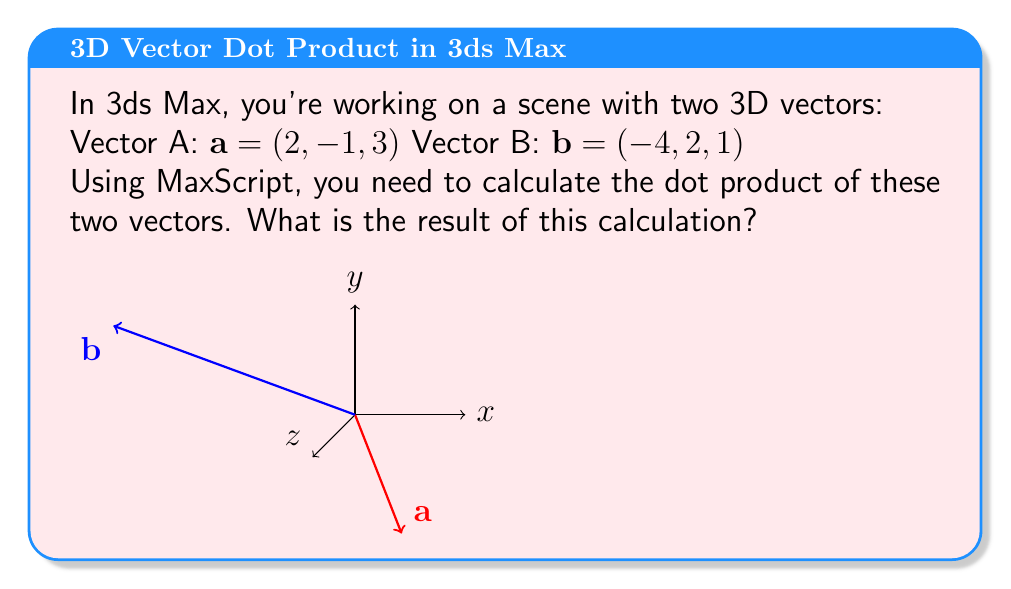Show me your answer to this math problem. To calculate the dot product of two 3D vectors, we multiply the corresponding components and sum the results. The formula for the dot product of vectors $\mathbf{a} = (a_1, a_2, a_3)$ and $\mathbf{b} = (b_1, b_2, b_3)$ is:

$$\mathbf{a} \cdot \mathbf{b} = a_1b_1 + a_2b_2 + a_3b_3$$

For the given vectors:

$\mathbf{a} = (2, -1, 3)$
$\mathbf{b} = (-4, 2, 1)$

Let's calculate each component:

1. $a_1b_1 = 2 \times (-4) = -8$
2. $a_2b_2 = (-1) \times 2 = -2$
3. $a_3b_3 = 3 \times 1 = 3$

Now, sum these results:

$$\mathbf{a} \cdot \mathbf{b} = (-8) + (-2) + 3 = -7$$

In MaxScript, this calculation could be performed using the dot product operator ('^.'):

```maxscript
a = [2, -1, 3]
b = [-4, 2, 1]
dotProduct = a ^. b
```

The result of this operation would be -7.
Answer: $-7$ 